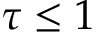<formula> <loc_0><loc_0><loc_500><loc_500>\tau \leq 1</formula> 